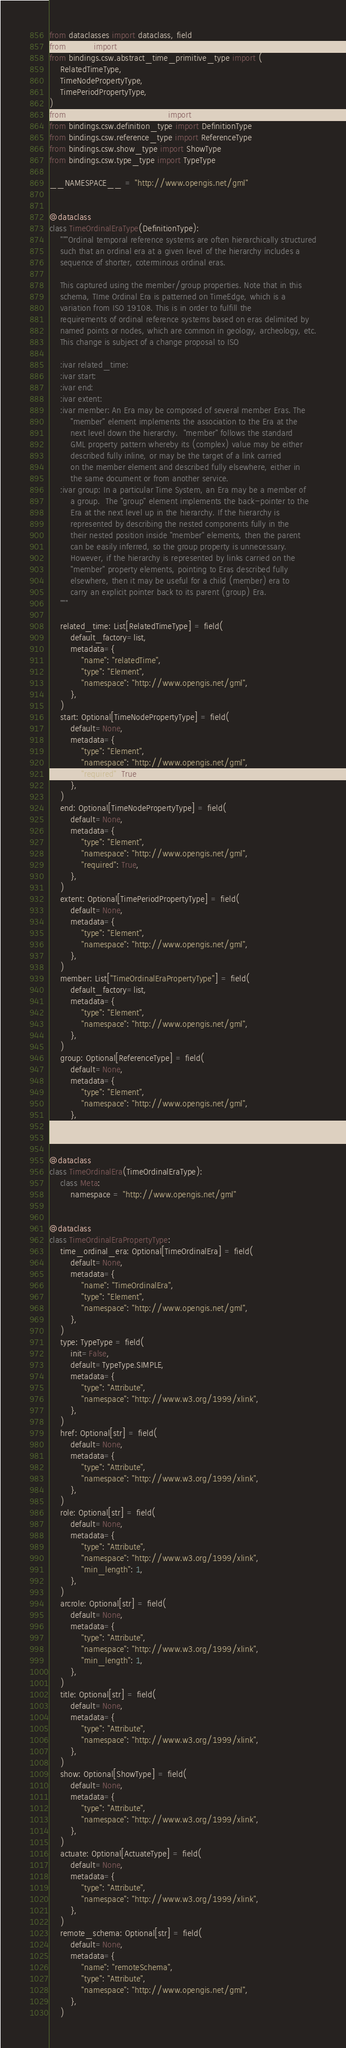Convert code to text. <code><loc_0><loc_0><loc_500><loc_500><_Python_>from dataclasses import dataclass, field
from typing import List, Optional
from bindings.csw.abstract_time_primitive_type import (
    RelatedTimeType,
    TimeNodePropertyType,
    TimePeriodPropertyType,
)
from bindings.csw.actuate_type import ActuateType
from bindings.csw.definition_type import DefinitionType
from bindings.csw.reference_type import ReferenceType
from bindings.csw.show_type import ShowType
from bindings.csw.type_type import TypeType

__NAMESPACE__ = "http://www.opengis.net/gml"


@dataclass
class TimeOrdinalEraType(DefinitionType):
    """Ordinal temporal reference systems are often hierarchically structured
    such that an ordinal era at a given level of the hierarchy includes a
    sequence of shorter, coterminous ordinal eras.

    This captured using the member/group properties. Note that in this
    schema, TIme Ordinal Era is patterned on TimeEdge, which is a
    variation from ISO 19108. This is in order to fulfill the
    requirements of ordinal reference systems based on eras delimited by
    named points or nodes, which are common in geology, archeology, etc.
    This change is subject of a change proposal to ISO

    :ivar related_time:
    :ivar start:
    :ivar end:
    :ivar extent:
    :ivar member: An Era may be composed of several member Eras. The
        "member" element implements the association to the Era at the
        next level down the hierarchy.  "member" follows the standard
        GML property pattern whereby its (complex) value may be either
        described fully inline, or may be the target of a link carried
        on the member element and described fully elsewhere, either in
        the same document or from another service.
    :ivar group: In a particular Time System, an Era may be a member of
        a group.  The "group" element implements the back-pointer to the
        Era at the next level up in the hierarchy. If the hierarchy is
        represented by describing the nested components fully in the
        their nested position inside "member" elements, then the parent
        can be easily inferred, so the group property is unnecessary.
        However, if the hierarchy is represented by links carried on the
        "member" property elements, pointing to Eras described fully
        elsewhere, then it may be useful for a child (member) era to
        carry an explicit pointer back to its parent (group) Era.
    """

    related_time: List[RelatedTimeType] = field(
        default_factory=list,
        metadata={
            "name": "relatedTime",
            "type": "Element",
            "namespace": "http://www.opengis.net/gml",
        },
    )
    start: Optional[TimeNodePropertyType] = field(
        default=None,
        metadata={
            "type": "Element",
            "namespace": "http://www.opengis.net/gml",
            "required": True,
        },
    )
    end: Optional[TimeNodePropertyType] = field(
        default=None,
        metadata={
            "type": "Element",
            "namespace": "http://www.opengis.net/gml",
            "required": True,
        },
    )
    extent: Optional[TimePeriodPropertyType] = field(
        default=None,
        metadata={
            "type": "Element",
            "namespace": "http://www.opengis.net/gml",
        },
    )
    member: List["TimeOrdinalEraPropertyType"] = field(
        default_factory=list,
        metadata={
            "type": "Element",
            "namespace": "http://www.opengis.net/gml",
        },
    )
    group: Optional[ReferenceType] = field(
        default=None,
        metadata={
            "type": "Element",
            "namespace": "http://www.opengis.net/gml",
        },
    )


@dataclass
class TimeOrdinalEra(TimeOrdinalEraType):
    class Meta:
        namespace = "http://www.opengis.net/gml"


@dataclass
class TimeOrdinalEraPropertyType:
    time_ordinal_era: Optional[TimeOrdinalEra] = field(
        default=None,
        metadata={
            "name": "TimeOrdinalEra",
            "type": "Element",
            "namespace": "http://www.opengis.net/gml",
        },
    )
    type: TypeType = field(
        init=False,
        default=TypeType.SIMPLE,
        metadata={
            "type": "Attribute",
            "namespace": "http://www.w3.org/1999/xlink",
        },
    )
    href: Optional[str] = field(
        default=None,
        metadata={
            "type": "Attribute",
            "namespace": "http://www.w3.org/1999/xlink",
        },
    )
    role: Optional[str] = field(
        default=None,
        metadata={
            "type": "Attribute",
            "namespace": "http://www.w3.org/1999/xlink",
            "min_length": 1,
        },
    )
    arcrole: Optional[str] = field(
        default=None,
        metadata={
            "type": "Attribute",
            "namespace": "http://www.w3.org/1999/xlink",
            "min_length": 1,
        },
    )
    title: Optional[str] = field(
        default=None,
        metadata={
            "type": "Attribute",
            "namespace": "http://www.w3.org/1999/xlink",
        },
    )
    show: Optional[ShowType] = field(
        default=None,
        metadata={
            "type": "Attribute",
            "namespace": "http://www.w3.org/1999/xlink",
        },
    )
    actuate: Optional[ActuateType] = field(
        default=None,
        metadata={
            "type": "Attribute",
            "namespace": "http://www.w3.org/1999/xlink",
        },
    )
    remote_schema: Optional[str] = field(
        default=None,
        metadata={
            "name": "remoteSchema",
            "type": "Attribute",
            "namespace": "http://www.opengis.net/gml",
        },
    )
</code> 